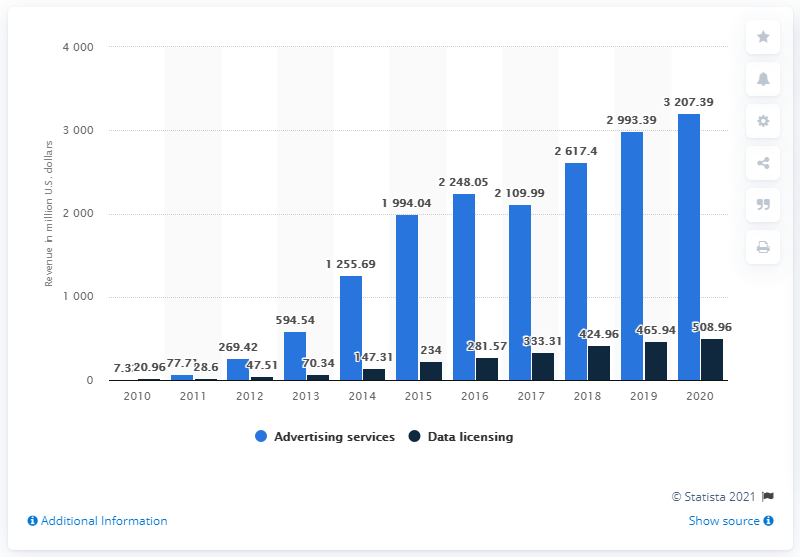Mention a couple of crucial points in this snapshot. In the previous year, Twitter generated a total revenue of 3207.39 million dollars. In the most recent fiscal period, Twitter generated $3207.39 in advertising revenue. 